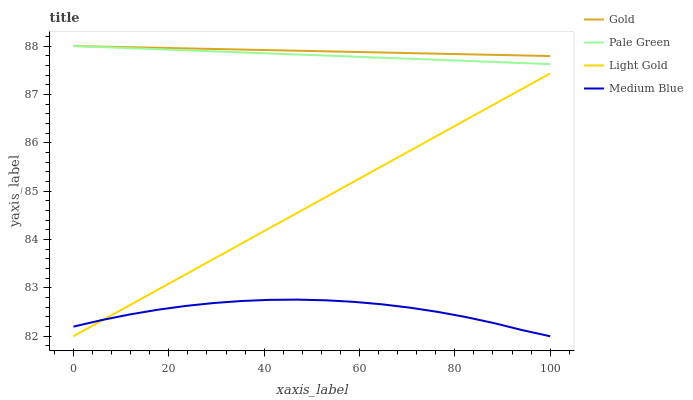Does Medium Blue have the minimum area under the curve?
Answer yes or no. Yes. Does Gold have the maximum area under the curve?
Answer yes or no. Yes. Does Pale Green have the minimum area under the curve?
Answer yes or no. No. Does Pale Green have the maximum area under the curve?
Answer yes or no. No. Is Light Gold the smoothest?
Answer yes or no. Yes. Is Medium Blue the roughest?
Answer yes or no. Yes. Is Pale Green the smoothest?
Answer yes or no. No. Is Pale Green the roughest?
Answer yes or no. No. Does Medium Blue have the lowest value?
Answer yes or no. Yes. Does Pale Green have the lowest value?
Answer yes or no. No. Does Gold have the highest value?
Answer yes or no. Yes. Does Light Gold have the highest value?
Answer yes or no. No. Is Medium Blue less than Gold?
Answer yes or no. Yes. Is Gold greater than Light Gold?
Answer yes or no. Yes. Does Medium Blue intersect Light Gold?
Answer yes or no. Yes. Is Medium Blue less than Light Gold?
Answer yes or no. No. Is Medium Blue greater than Light Gold?
Answer yes or no. No. Does Medium Blue intersect Gold?
Answer yes or no. No. 